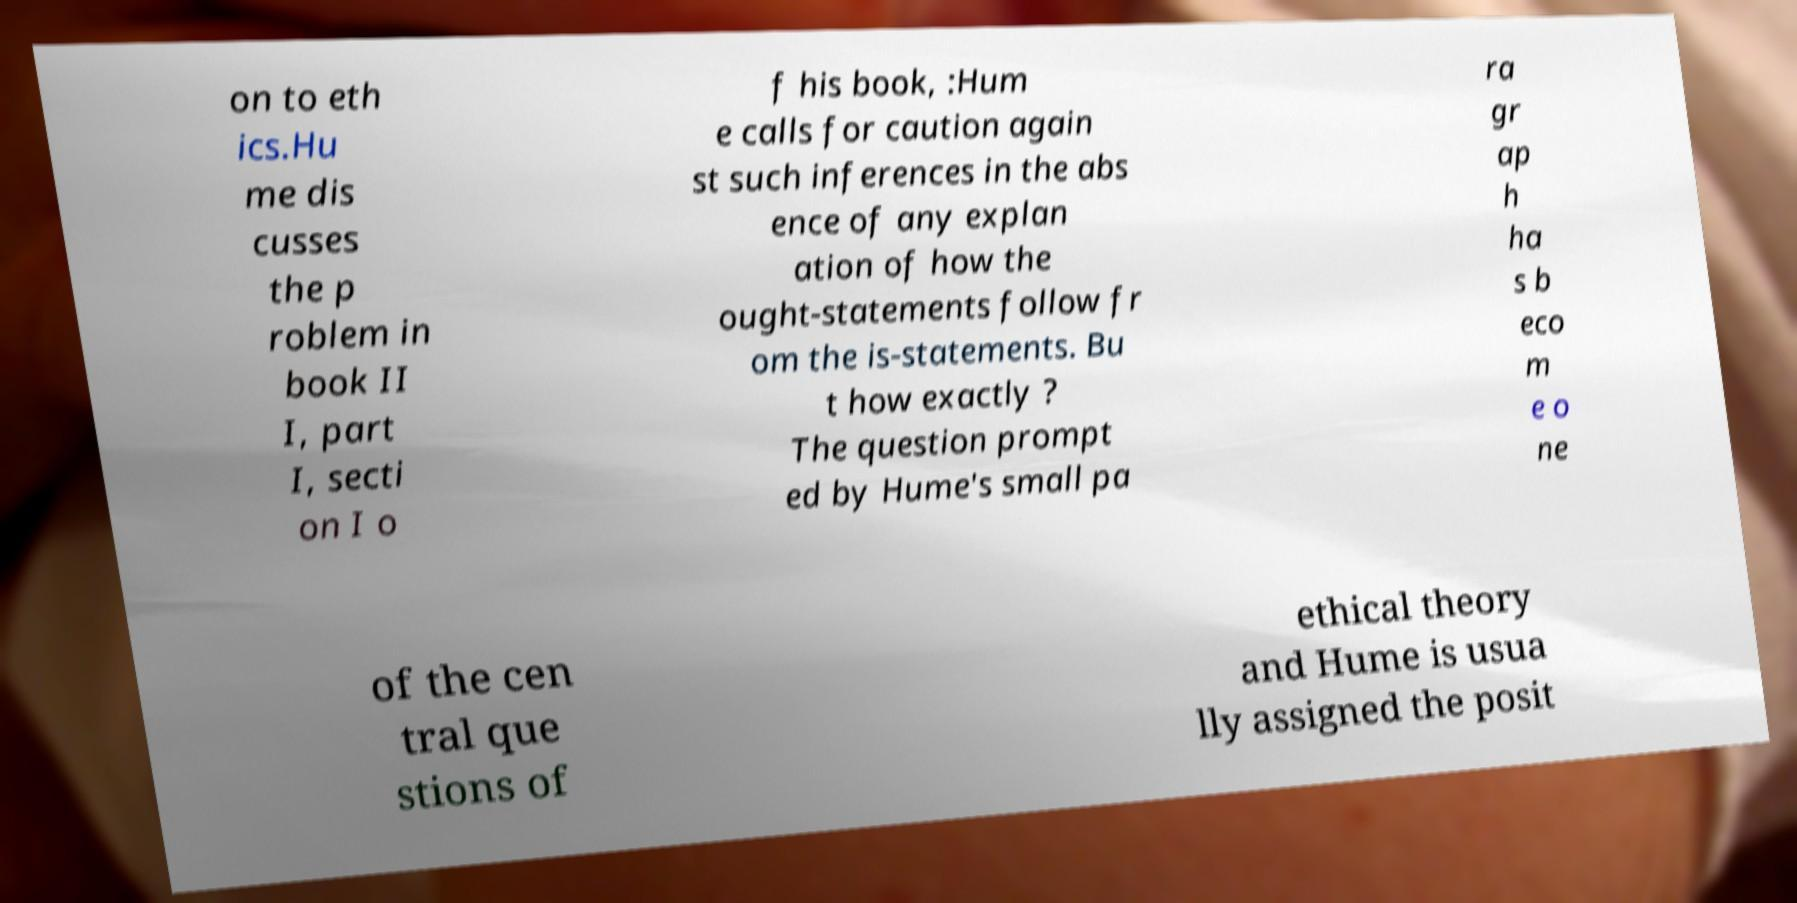For documentation purposes, I need the text within this image transcribed. Could you provide that? on to eth ics.Hu me dis cusses the p roblem in book II I, part I, secti on I o f his book, :Hum e calls for caution again st such inferences in the abs ence of any explan ation of how the ought-statements follow fr om the is-statements. Bu t how exactly ? The question prompt ed by Hume's small pa ra gr ap h ha s b eco m e o ne of the cen tral que stions of ethical theory and Hume is usua lly assigned the posit 